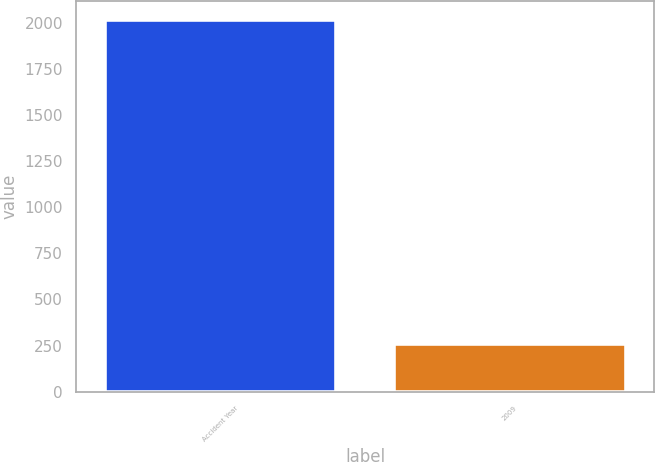Convert chart to OTSL. <chart><loc_0><loc_0><loc_500><loc_500><bar_chart><fcel>Accident Year<fcel>2009<nl><fcel>2017<fcel>257<nl></chart> 